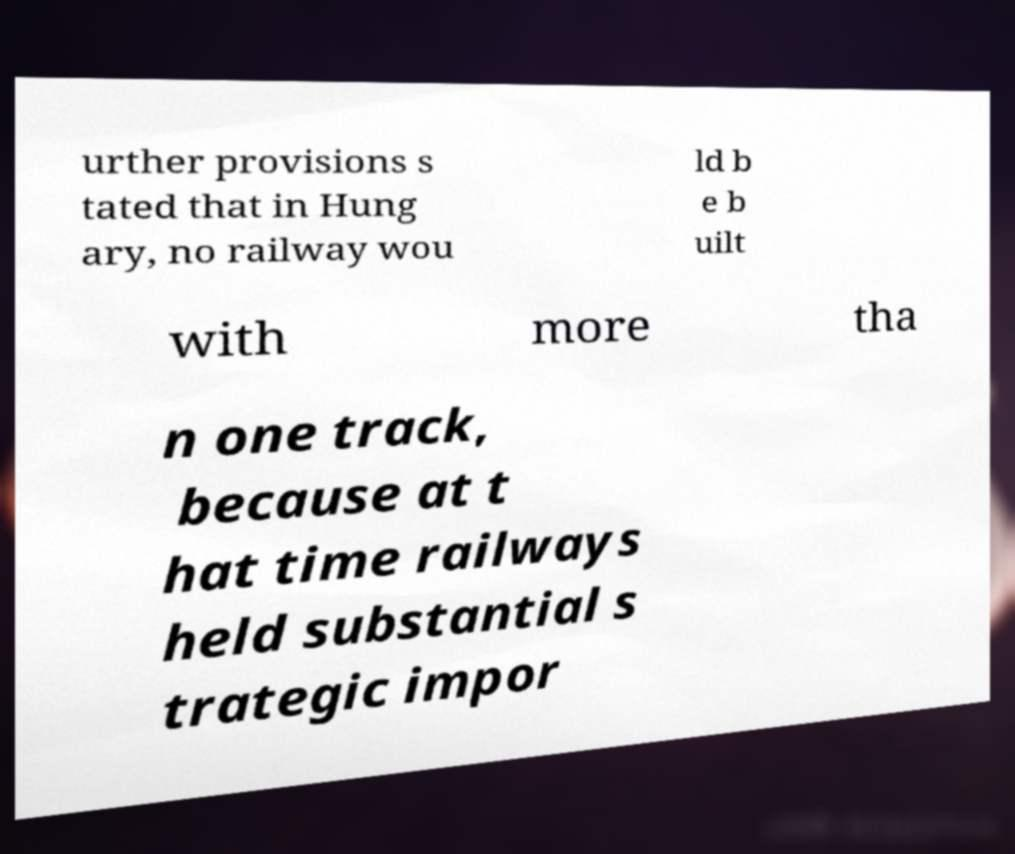There's text embedded in this image that I need extracted. Can you transcribe it verbatim? urther provisions s tated that in Hung ary, no railway wou ld b e b uilt with more tha n one track, because at t hat time railways held substantial s trategic impor 